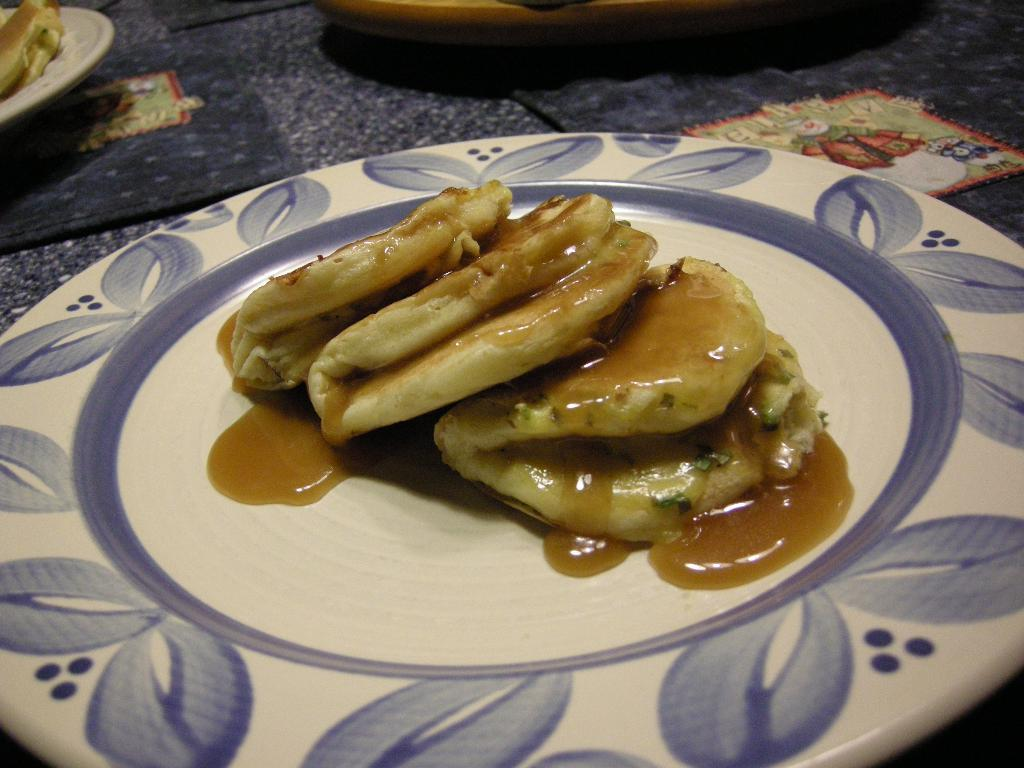What type of food is on the plate in the image? The image shows food with sauce on a plate. Can you describe the setting where the plate is located? The plate is on a table with additional plates containing food. What is the account number of the person eating the food in the image? There is no information about an account number or a person eating the food in the image. 